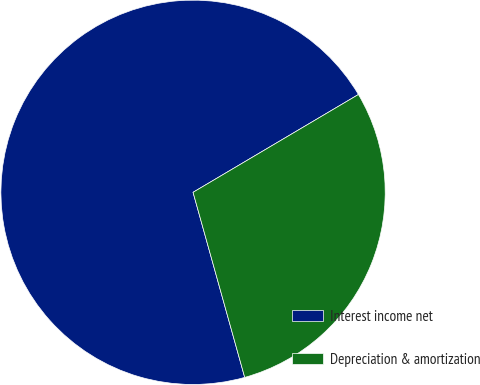<chart> <loc_0><loc_0><loc_500><loc_500><pie_chart><fcel>Interest income net<fcel>Depreciation & amortization<nl><fcel>70.83%<fcel>29.17%<nl></chart> 